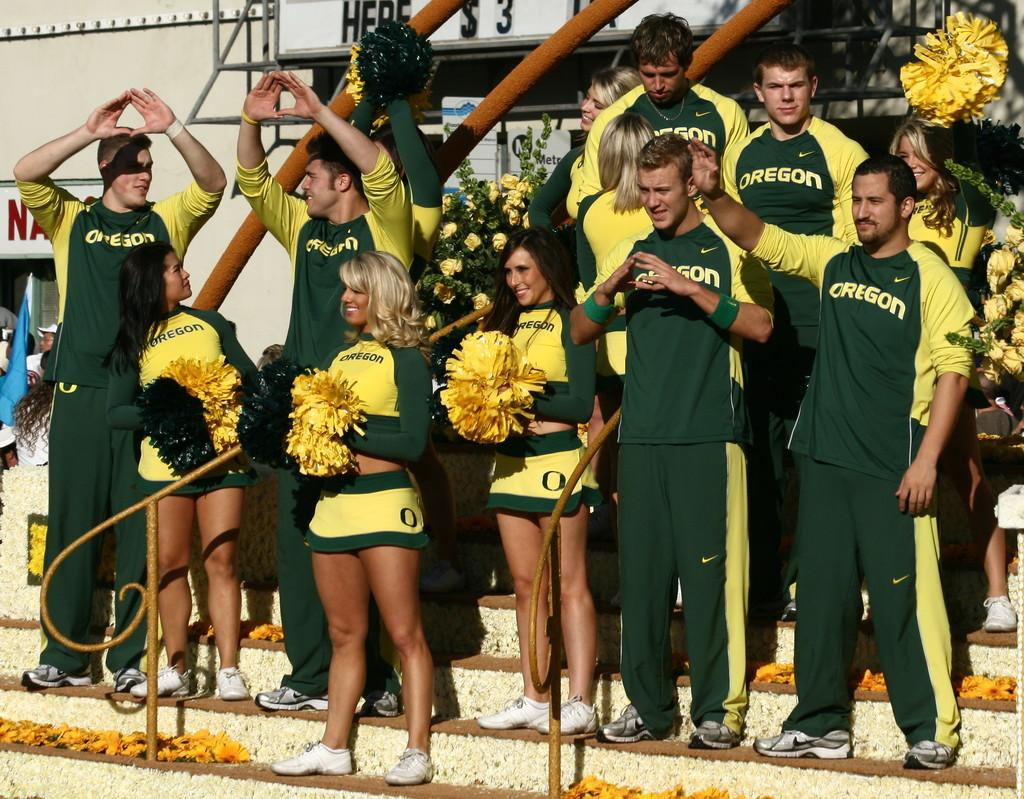<image>
Summarize the visual content of the image. Oregon cheerleaders stand on bleachers cheering for their team. 